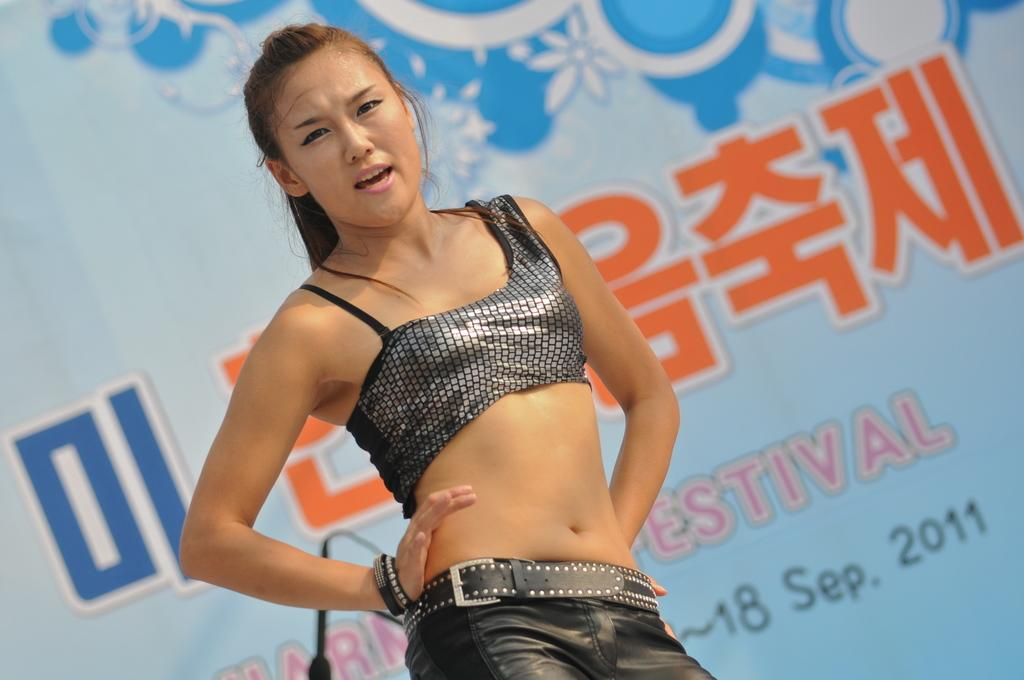Who is the main subject in the image? There is a girl in the center of the image. What can be seen in the background of the image? There is a banner in the background of the image. What type of canvas is the girl painting in the image? There is no canvas or painting activity present in the image. What type of quilt is the girl using to cover herself in the image? There is no quilt present in the image. 